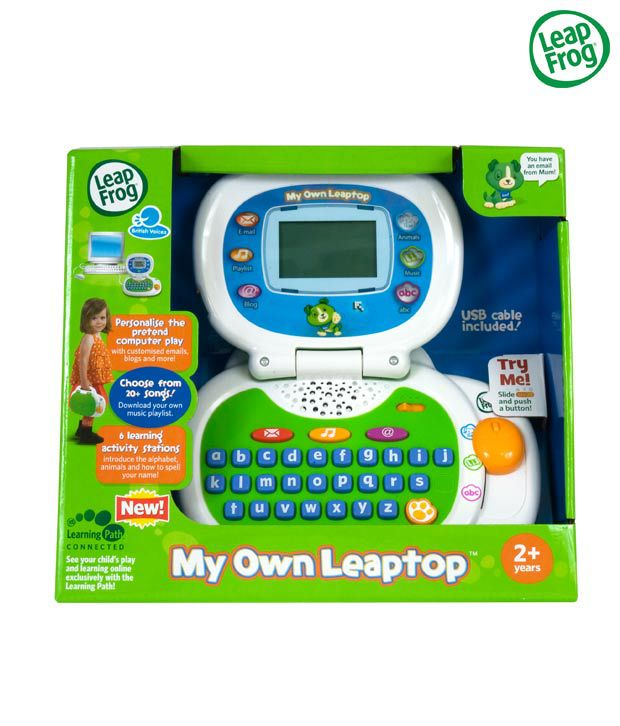What are the benefits of the 'Learning Path' feature mentioned on the packaging? The 'Learning Path' feature allows parents to track their child’s interaction with the toy, monitoring which activities engage them the most and assessing their learning progress. It offers insights into the child’s development, helping parents and educators tailor the educational content to better suit the child's learning style and speed. Can parents receive recommendations on how to further their child's development with this toy? Yes, based on the data collected through the 'Learning Path', parents could receive customized recommendations on additional activities or games that might benefit their child’s educational journey, ensuring the toy continues to meet the developing needs of their child. 